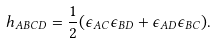Convert formula to latex. <formula><loc_0><loc_0><loc_500><loc_500>h _ { A B C D } = \frac { 1 } { 2 } ( \epsilon _ { A C } \epsilon _ { B D } + \epsilon _ { A D } \epsilon _ { B C } ) .</formula> 